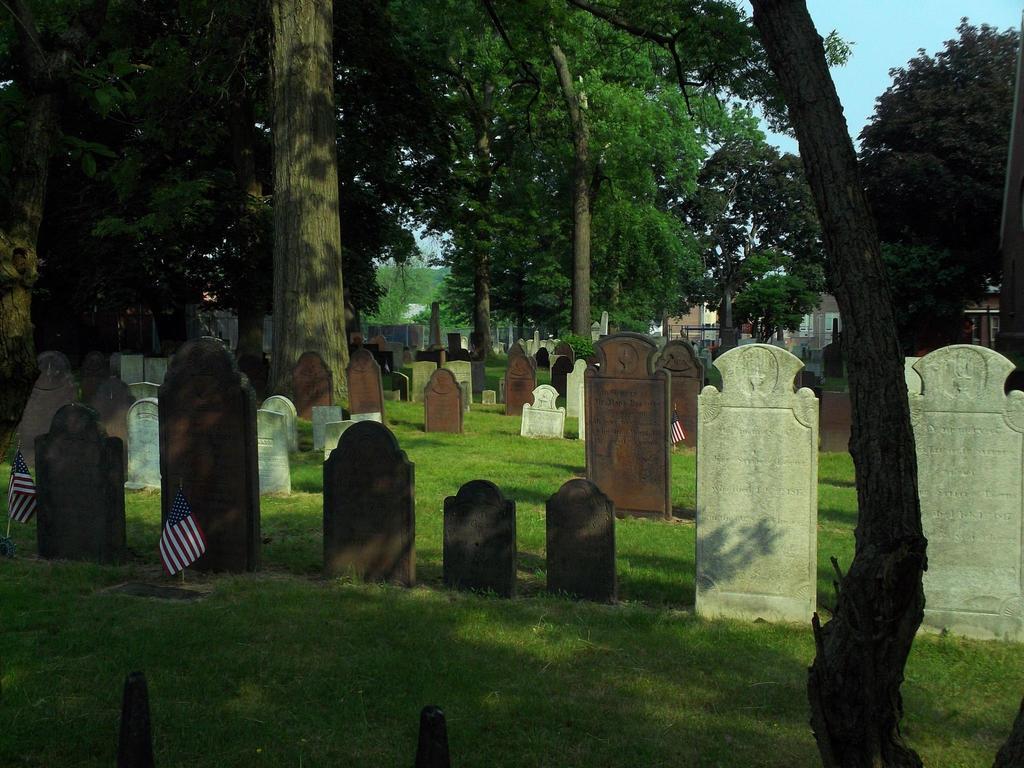Can you describe this image briefly? In this image I can see few cemetery in brown and white color. I can see few flags,trees,buildings and green grass. The sky is in blue color. 